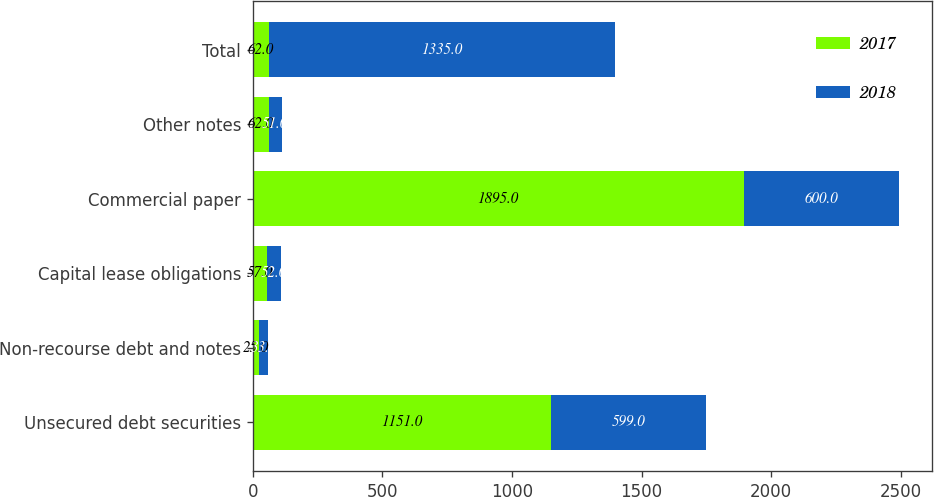<chart> <loc_0><loc_0><loc_500><loc_500><stacked_bar_chart><ecel><fcel>Unsecured debt securities<fcel>Non-recourse debt and notes<fcel>Capital lease obligations<fcel>Commercial paper<fcel>Other notes<fcel>Total<nl><fcel>2017<fcel>1151<fcel>25<fcel>57<fcel>1895<fcel>62<fcel>62<nl><fcel>2018<fcel>599<fcel>33<fcel>52<fcel>600<fcel>51<fcel>1335<nl></chart> 